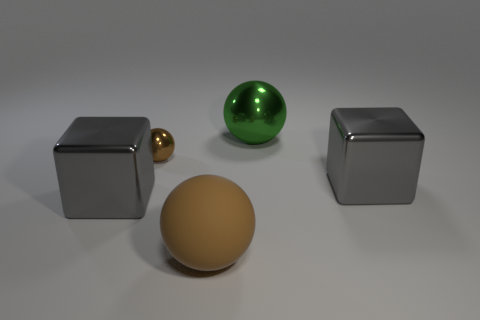Add 2 small blue shiny cylinders. How many objects exist? 7 Subtract all spheres. How many objects are left? 2 Subtract 0 red spheres. How many objects are left? 5 Subtract all large metallic blocks. Subtract all small brown shiny spheres. How many objects are left? 2 Add 2 tiny brown metal things. How many tiny brown metal things are left? 3 Add 1 big rubber objects. How many big rubber objects exist? 2 